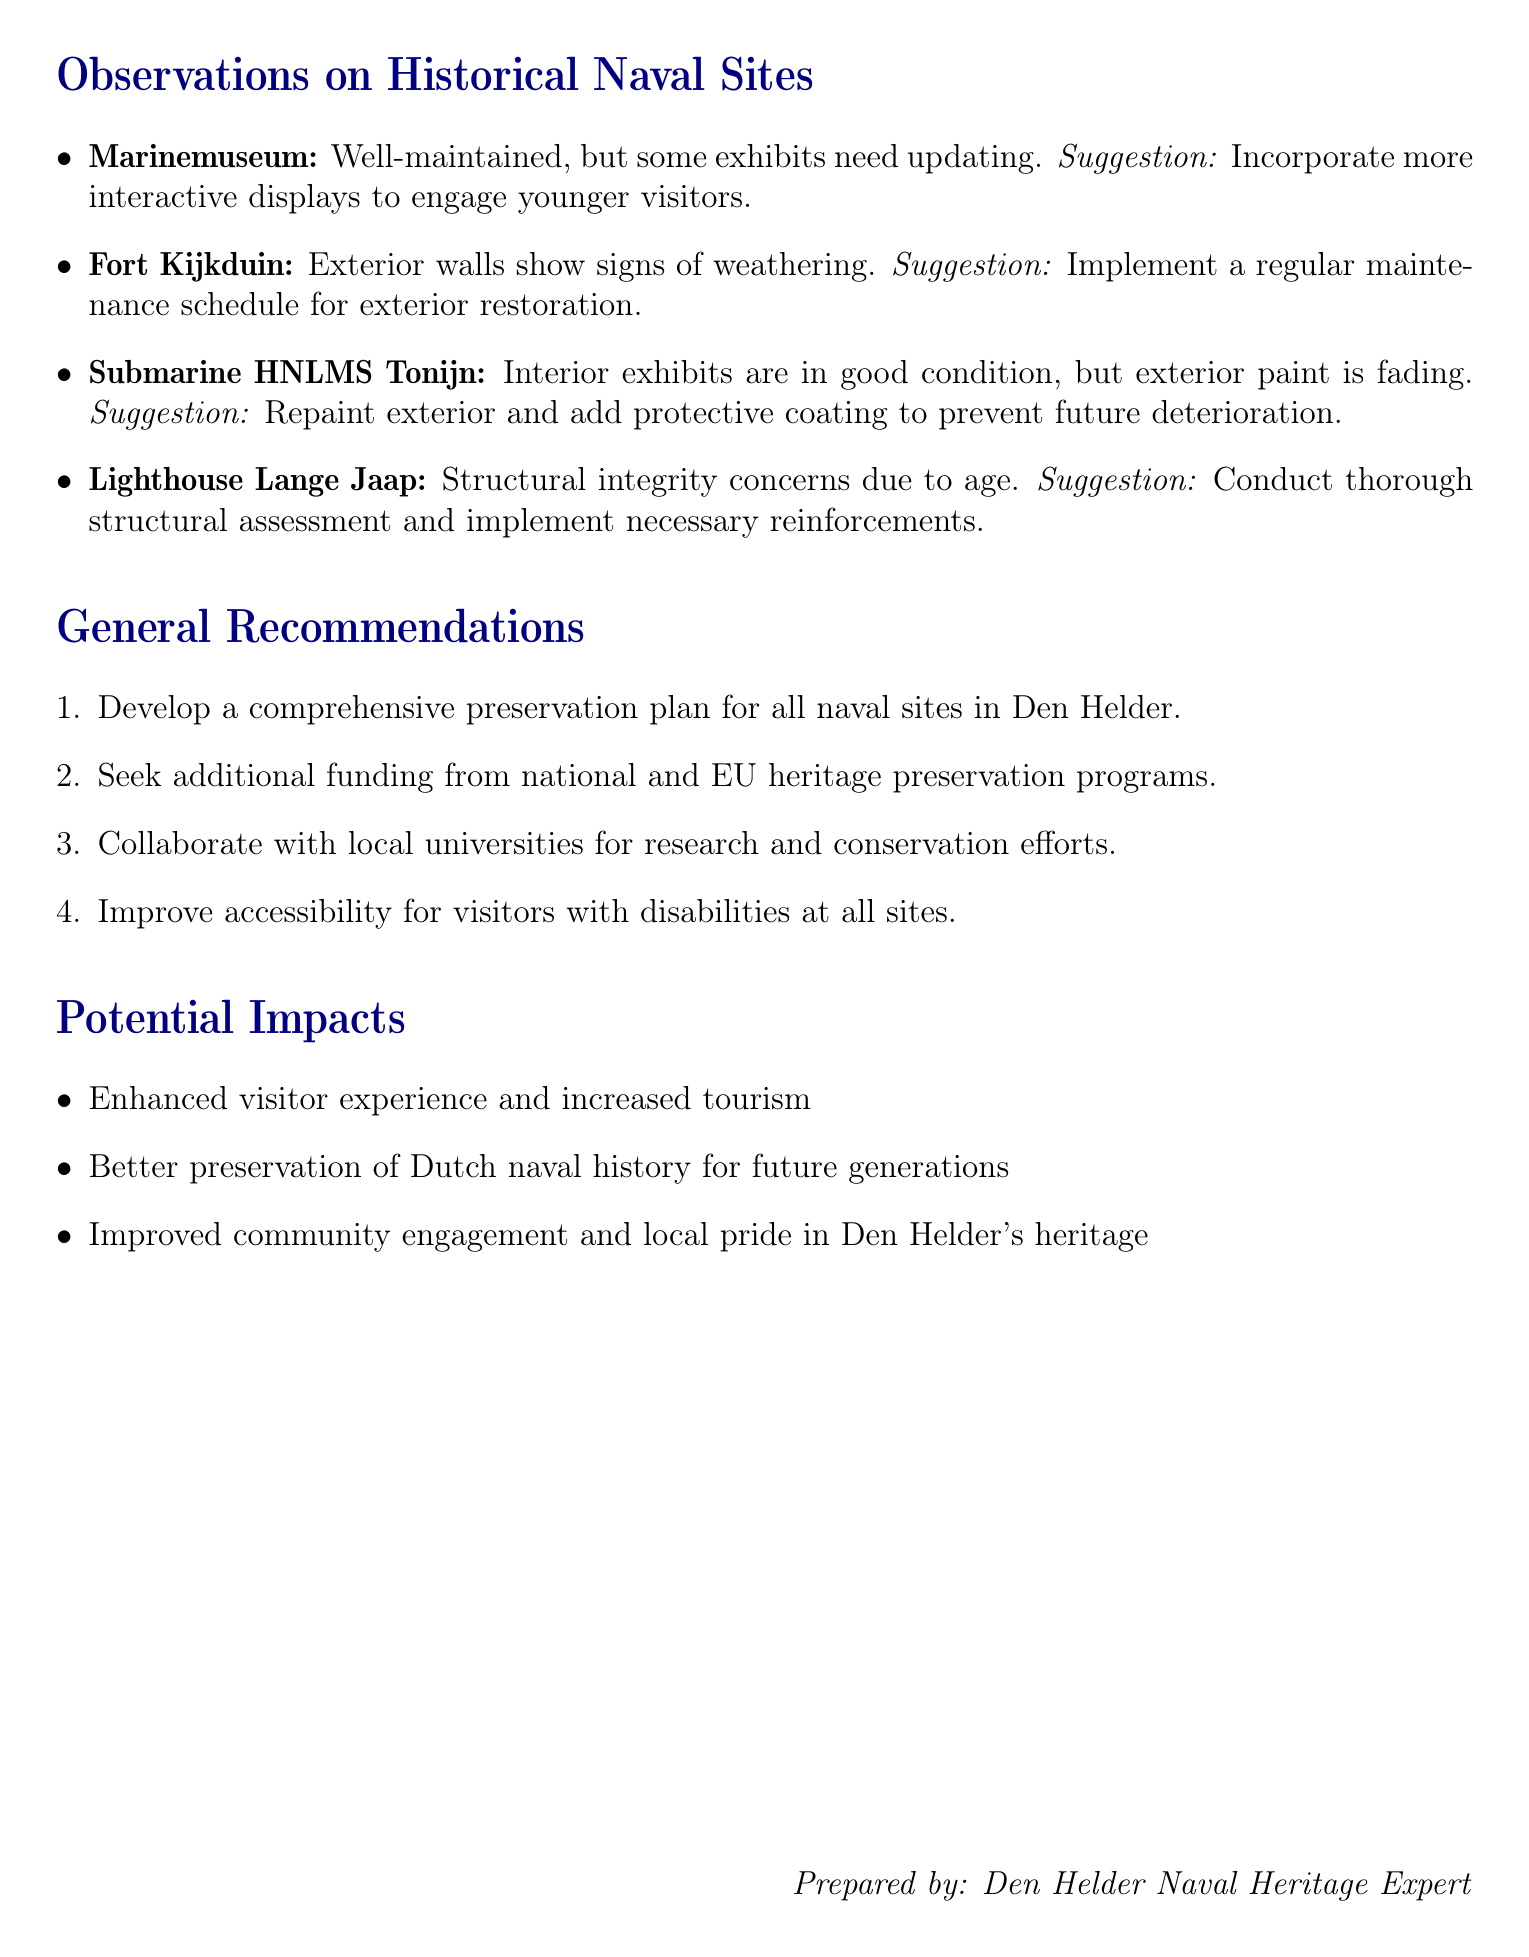What is the preservation state of the Marinemuseum? The Marinemuseum is described as well-maintained, but some exhibits need updating.
Answer: Well-maintained, but some exhibits need updating What is one suggestion for improving Fort Kijkduin? The suggestion for improving Fort Kijkduin is to implement a regular maintenance schedule for exterior restoration.
Answer: Implement a regular maintenance schedule for exterior restoration What structural issue is mentioned regarding the Lighthouse Lange Jaap? The document mentions that there are structural integrity concerns due to age regarding the Lighthouse Lange Jaap.
Answer: Structural integrity concerns due to age How many general recommendations are listed in the document? The document lists four general recommendations for preservation.
Answer: Four What is one potential impact of improving the preservation of naval sites? Enhanced visitor experience and increased tourism is mentioned as a potential impact of preservation improvements.
Answer: Enhanced visitor experience and increased tourism What is the state of the exterior of Submarine HNLMS Tonijn? The document states that the exterior paint of Submarine HNLMS Tonijn is fading.
Answer: Exterior paint is fading What type of institutions does the document suggest collaborating with for conservation efforts? The document suggests collaborating with local universities for research and conservation efforts.
Answer: Local universities What should be incorporated more in the Marinemuseum according to the suggestions? The suggestion is to incorporate more interactive displays to engage younger visitors in the Marinemuseum.
Answer: More interactive displays to engage younger visitors What is one of the suggested actions for the preservation plan? One suggested action is to seek additional funding from national and EU heritage preservation programs.
Answer: Seek additional funding from national and EU heritage preservation programs 